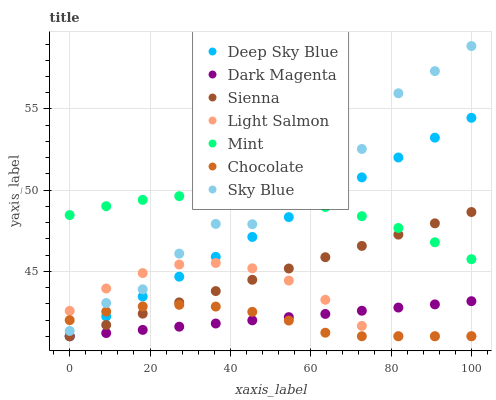Does Chocolate have the minimum area under the curve?
Answer yes or no. Yes. Does Sky Blue have the maximum area under the curve?
Answer yes or no. Yes. Does Dark Magenta have the minimum area under the curve?
Answer yes or no. No. Does Dark Magenta have the maximum area under the curve?
Answer yes or no. No. Is Dark Magenta the smoothest?
Answer yes or no. Yes. Is Sky Blue the roughest?
Answer yes or no. Yes. Is Chocolate the smoothest?
Answer yes or no. No. Is Chocolate the roughest?
Answer yes or no. No. Does Light Salmon have the lowest value?
Answer yes or no. Yes. Does Sky Blue have the lowest value?
Answer yes or no. No. Does Sky Blue have the highest value?
Answer yes or no. Yes. Does Dark Magenta have the highest value?
Answer yes or no. No. Is Light Salmon less than Mint?
Answer yes or no. Yes. Is Mint greater than Light Salmon?
Answer yes or no. Yes. Does Sky Blue intersect Light Salmon?
Answer yes or no. Yes. Is Sky Blue less than Light Salmon?
Answer yes or no. No. Is Sky Blue greater than Light Salmon?
Answer yes or no. No. Does Light Salmon intersect Mint?
Answer yes or no. No. 